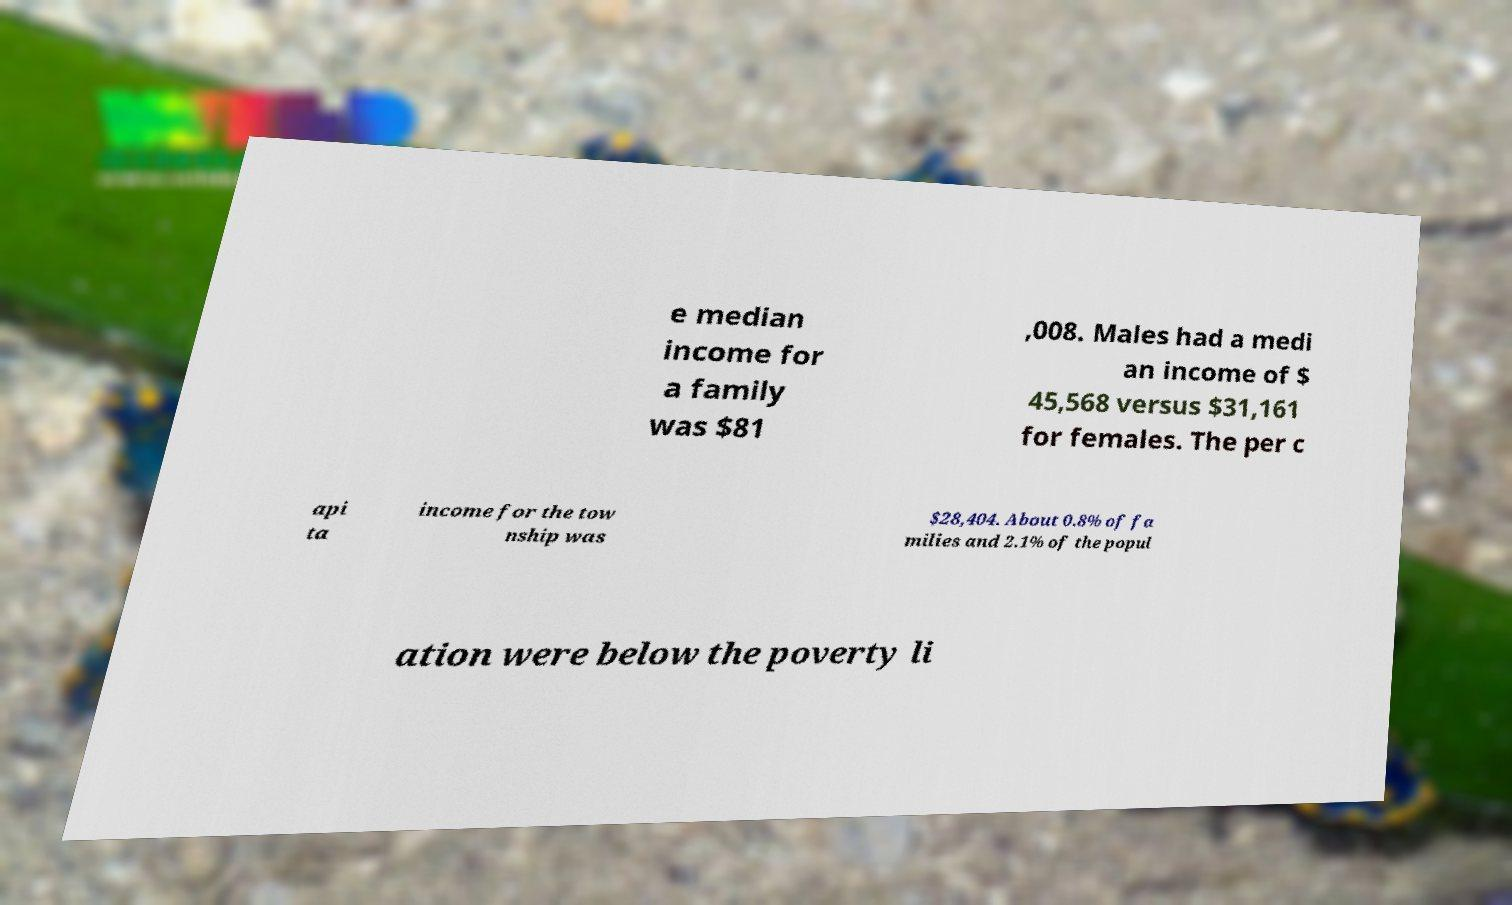For documentation purposes, I need the text within this image transcribed. Could you provide that? e median income for a family was $81 ,008. Males had a medi an income of $ 45,568 versus $31,161 for females. The per c api ta income for the tow nship was $28,404. About 0.8% of fa milies and 2.1% of the popul ation were below the poverty li 